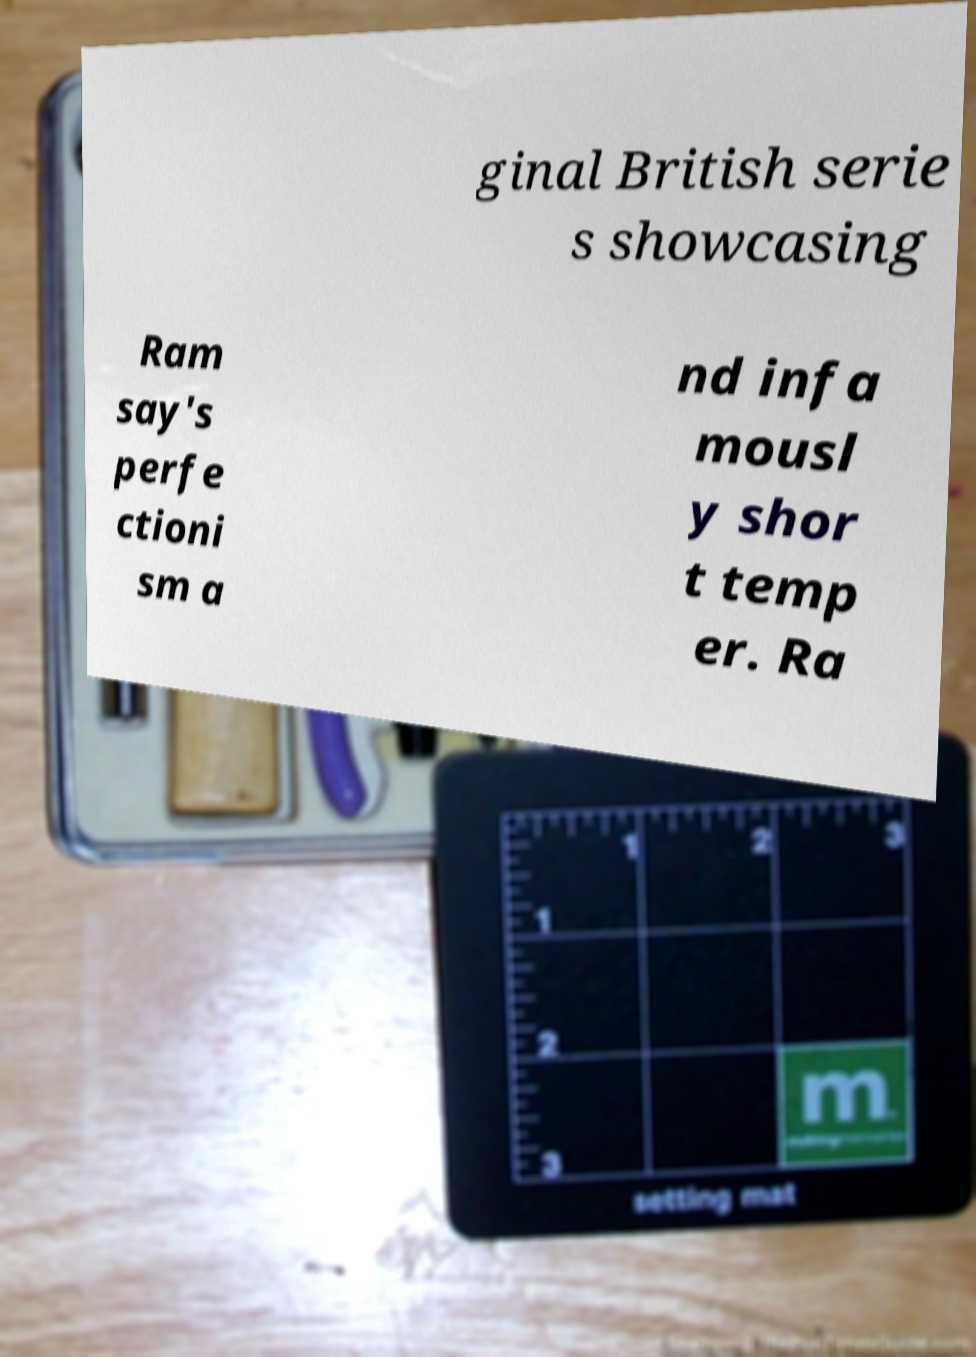Could you extract and type out the text from this image? ginal British serie s showcasing Ram say's perfe ctioni sm a nd infa mousl y shor t temp er. Ra 